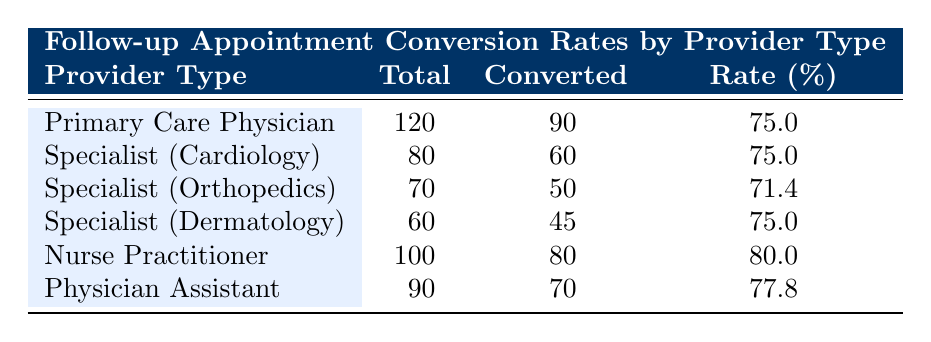What is the conversion rate for Nurse Practitioners? Looking at the table, the row for Nurse Practitioners shows a conversion rate percentage of 80.0
Answer: 80.0 Which provider type has the highest number of converted follow-up appointments? By comparing the 'Converted' column, Primary Care Physician has the highest number with 90 converted follow-up appointments
Answer: Primary Care Physician What is the average conversion rate percentage for all provider types? To calculate the average, sum the conversion rates: (75.0 + 75.0 + 71.4 + 75.0 + 80.0 + 77.8) = 454.2, then divide by the number of provider types, which is 6. Therefore, the average conversion rate is 454.2 / 6 = 75.7
Answer: 75.7 Is the conversion rate for Specialist (Orthopedics) higher than that for Physician Assistant? The conversion rate for Specialist (Orthopedics) is 71.4, while the rate for Physician Assistant is 77.8. Since 71.4 is less than 77.8, the statement is false
Answer: No Which provider type has the lowest conversion rate? Reviewing the conversion rates, Specialist (Orthopedics) has the lowest at 71.4% compared to the other provider types
Answer: Specialist (Orthopedics) How many total follow-up appointments were scheduled for Specialists (Cardiology) and Specialists (Dermatology) combined? Adding the total follow-up appointments for both Specialist types: 80 (Cardiology) + 60 (Dermatology) = 140 total appointments
Answer: 140 Is the conversion rate for Primary Care Physicians the same as that for Dermatologists? Both Primary Care Physicians and Dermatologists have a conversion rate of 75.0%, which means they are the same
Answer: Yes What is the difference in the number of total follow-up appointments between Nurse Practitioners and Primary Care Physicians? Nurse Practitioners have 100 total appointments and Primary Care Physicians have 120. Therefore, the difference is 120 - 100 = 20
Answer: 20 